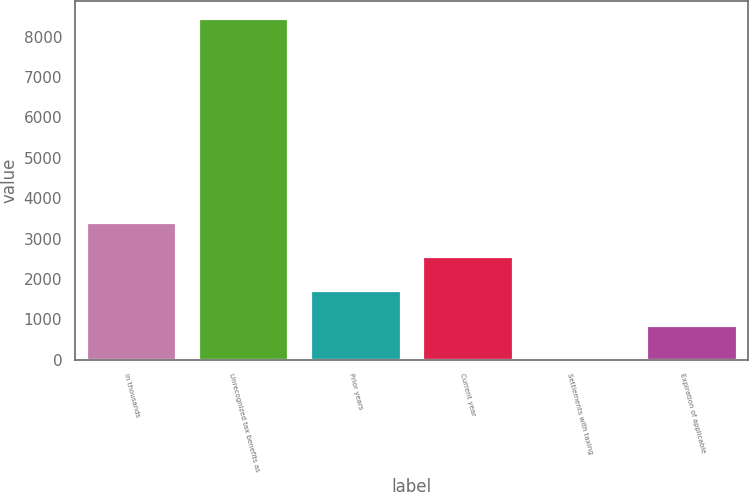<chart> <loc_0><loc_0><loc_500><loc_500><bar_chart><fcel>in thousands<fcel>Unrecognized tax benefits as<fcel>Prior years<fcel>Current year<fcel>Settlements with taxing<fcel>Expiration of applicable<nl><fcel>3379.6<fcel>8447<fcel>1690.48<fcel>2535.04<fcel>1.36<fcel>845.92<nl></chart> 